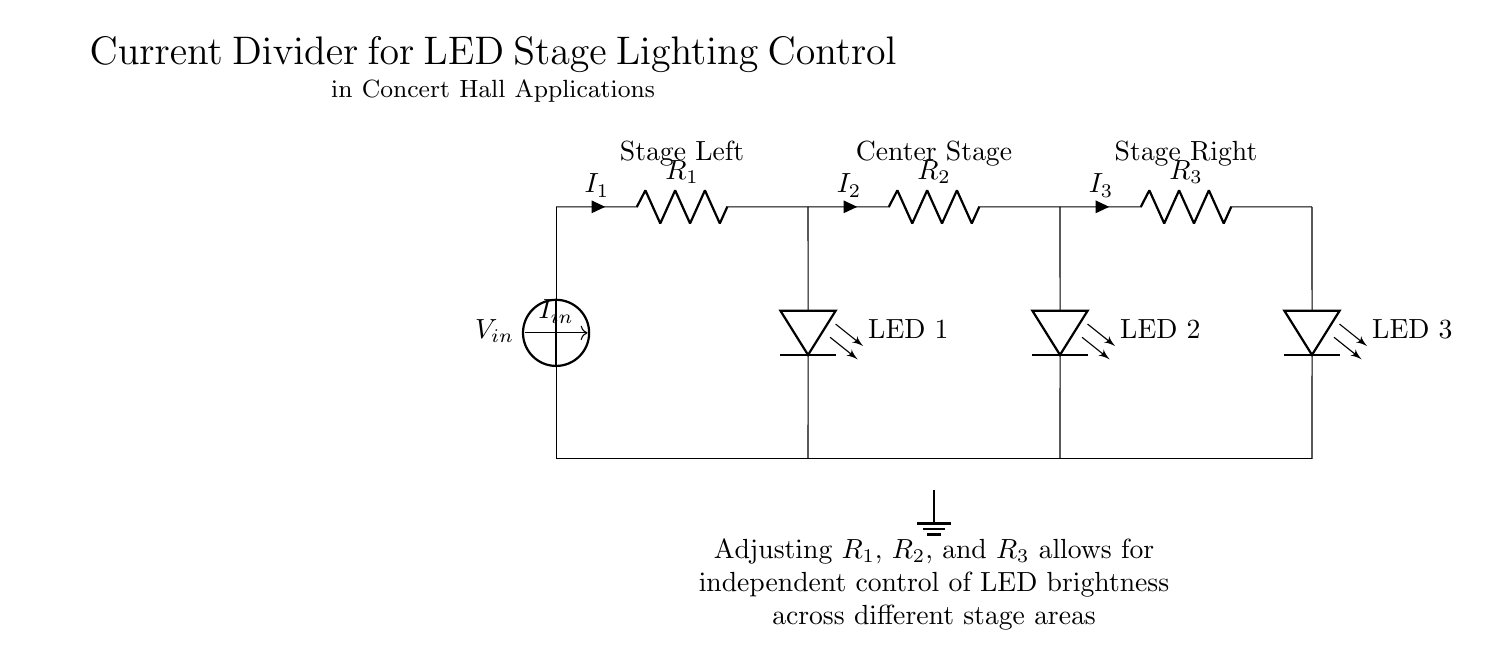What is the input current represented in this circuit? The input current is denoted as I_in, which is the current flowing into the circuit from the power supply.
Answer: I_in How many resistors are present in this circuit? There are three resistors shown in the circuit, labeled R_1, R_2, and R_3.
Answer: 3 Which LED is connected to the first resistor? The first LED is labeled LED 1 and is connected to the resistor R_1.
Answer: LED 1 What happens when R_1, R_2, and R_3 are adjusted? Adjusting the values of R_1, R_2, and R_3 allows for independent control of the brightness of the LEDs in the respective stages of the circuit.
Answer: Independent control What is the purpose of the current divider in this circuit? The purpose of the current divider is to split the input current I_in into different paths through the resistors, allowing for controlled brightness levels of the LEDs used in stage lighting.
Answer: Controlled brightness How are the ground connections represented in the circuit? The ground is represented by a horizontal line at the bottom of the circuit with a ground symbol indicating the common return for the current.
Answer: Ground symbol 